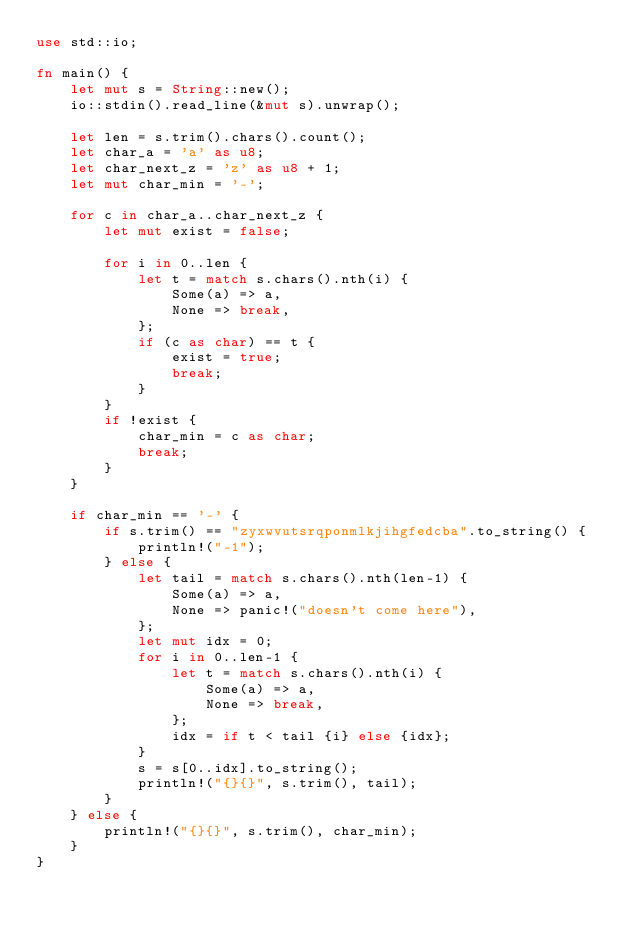<code> <loc_0><loc_0><loc_500><loc_500><_Rust_>use std::io;

fn main() {
    let mut s = String::new();
    io::stdin().read_line(&mut s).unwrap();

    let len = s.trim().chars().count();
    let char_a = 'a' as u8;
    let char_next_z = 'z' as u8 + 1;
    let mut char_min = '-';

    for c in char_a..char_next_z {
        let mut exist = false;

        for i in 0..len {
            let t = match s.chars().nth(i) {
                Some(a) => a,
                None => break,
            };
            if (c as char) == t {
                exist = true;
                break;
            }
        }
        if !exist {
            char_min = c as char;
            break;
        }
    }

    if char_min == '-' {
        if s.trim() == "zyxwvutsrqponmlkjihgfedcba".to_string() {
            println!("-1");
        } else {
            let tail = match s.chars().nth(len-1) {
                Some(a) => a,
                None => panic!("doesn't come here"),
            };
            let mut idx = 0;
            for i in 0..len-1 {
                let t = match s.chars().nth(i) {
                    Some(a) => a,
                    None => break,
                };
                idx = if t < tail {i} else {idx};
            }
            s = s[0..idx].to_string();
            println!("{}{}", s.trim(), tail);
        }
    } else {
        println!("{}{}", s.trim(), char_min);
    }
}</code> 